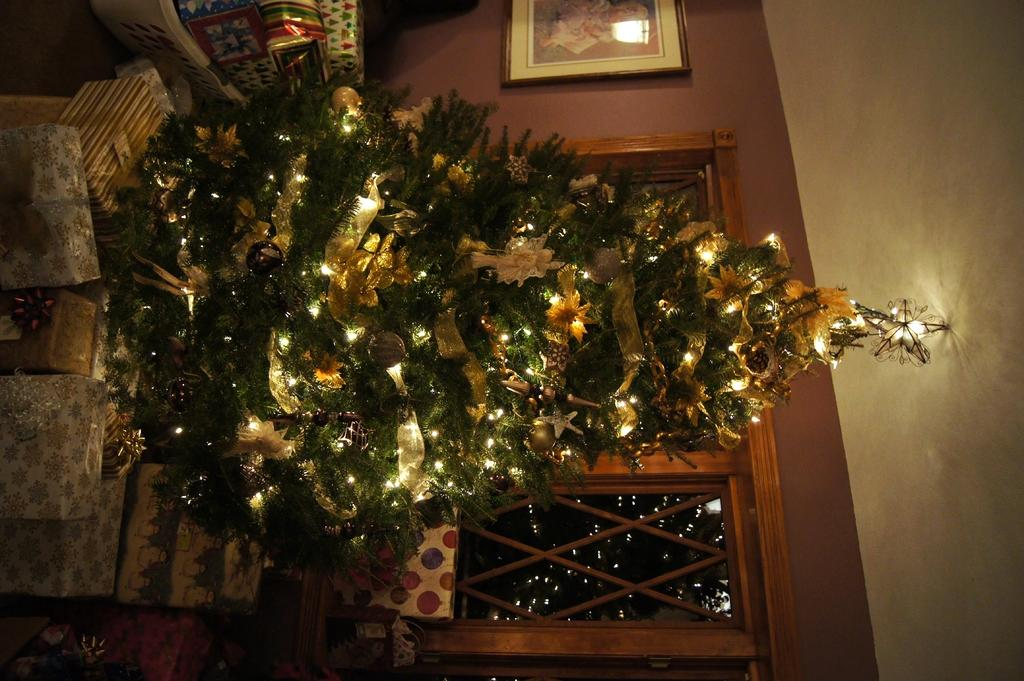What type of tree is in the image? There is a colorful Christmas tree in the image. What decorations are on the tree? Lights are visible on the tree. What is present on the wall in the image? A photo frame is attached to the wall. Where is the window located in the image? There is a window at the bottom of the image. What type of cloud is visible through the window in the image? There is no cloud visible through the window in the image; the window is at the bottom of the image. 